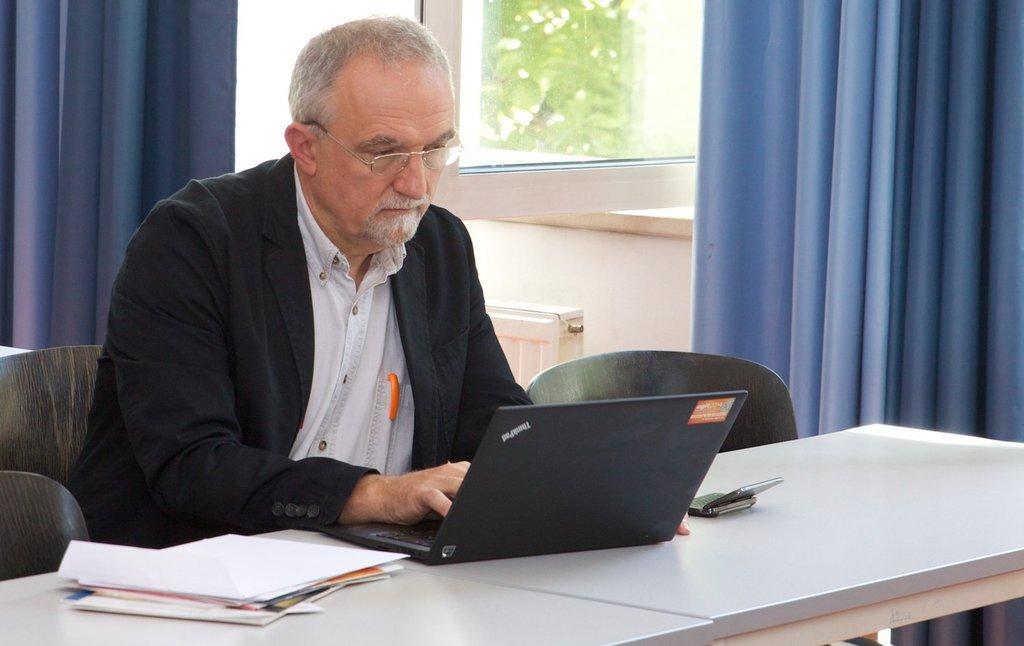What is the man in the image doing? The man is sitting on a chair in the image. What is located near the man? There is a table in the image. What electronic device is on the table? A laptop is present on the table. Are there any other items on the table? Yes, there are additional items on the table. What can be seen on the window in the image? There are curtains on a window in the image. What type of operation is the man performing on the laptop in the image? The image does not provide information about any specific operation the man might be performing on the laptop. 